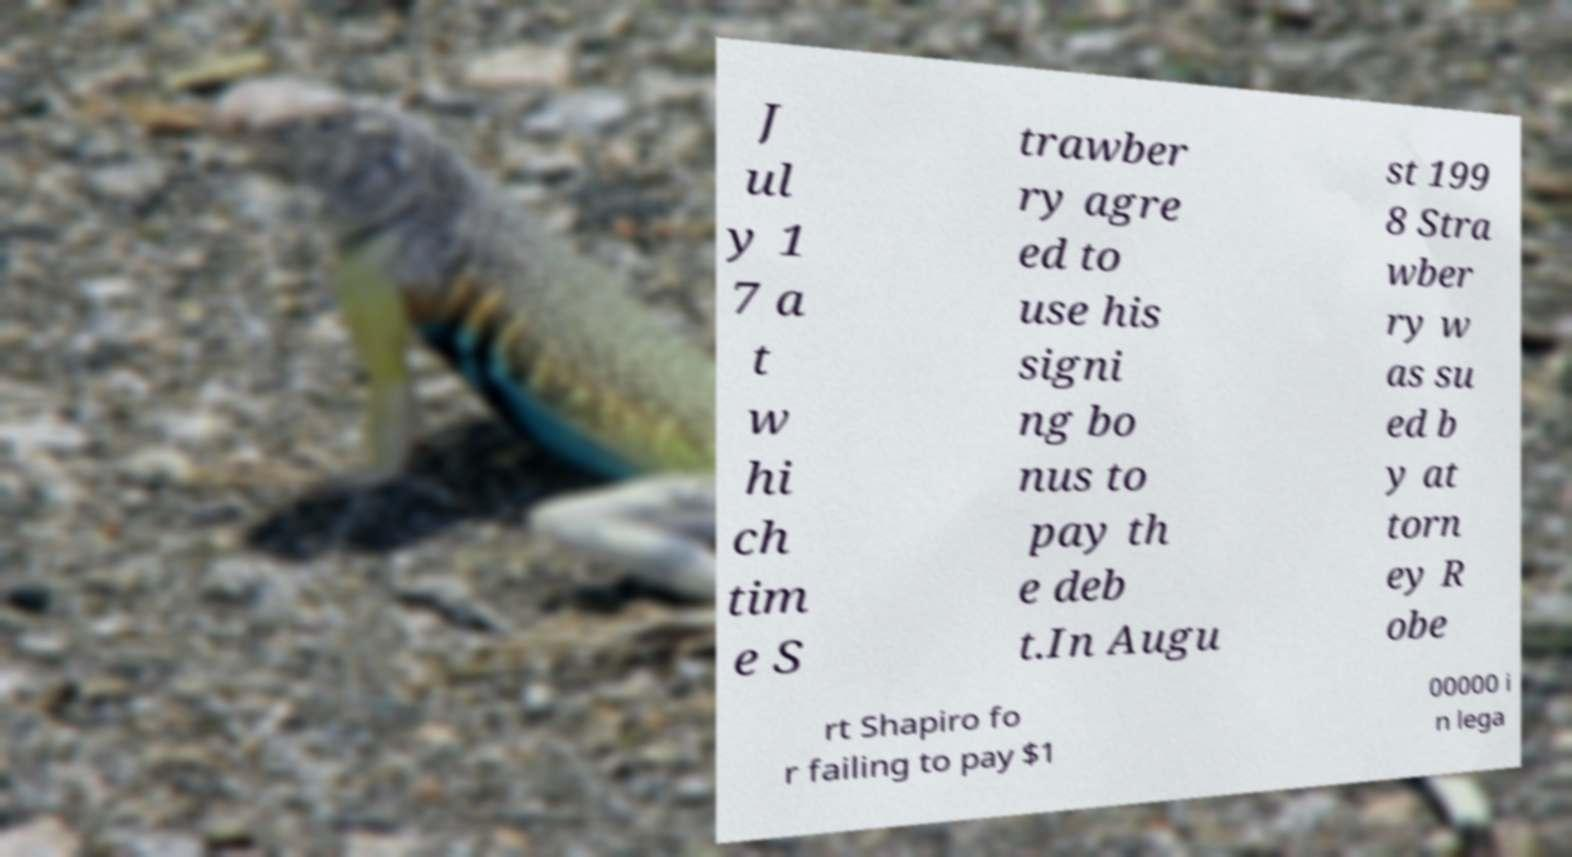For documentation purposes, I need the text within this image transcribed. Could you provide that? J ul y 1 7 a t w hi ch tim e S trawber ry agre ed to use his signi ng bo nus to pay th e deb t.In Augu st 199 8 Stra wber ry w as su ed b y at torn ey R obe rt Shapiro fo r failing to pay $1 00000 i n lega 